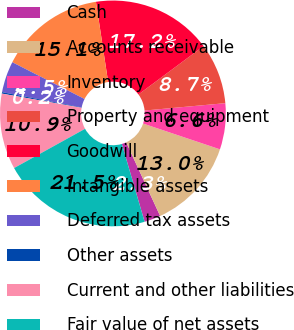Convert chart. <chart><loc_0><loc_0><loc_500><loc_500><pie_chart><fcel>Cash<fcel>Accounts receivable<fcel>Inventory<fcel>Property and equipment<fcel>Goodwill<fcel>Intangible assets<fcel>Deferred tax assets<fcel>Other assets<fcel>Current and other liabilities<fcel>Fair value of net assets<nl><fcel>2.34%<fcel>12.98%<fcel>6.6%<fcel>8.72%<fcel>17.23%<fcel>15.11%<fcel>4.47%<fcel>0.21%<fcel>10.85%<fcel>21.49%<nl></chart> 